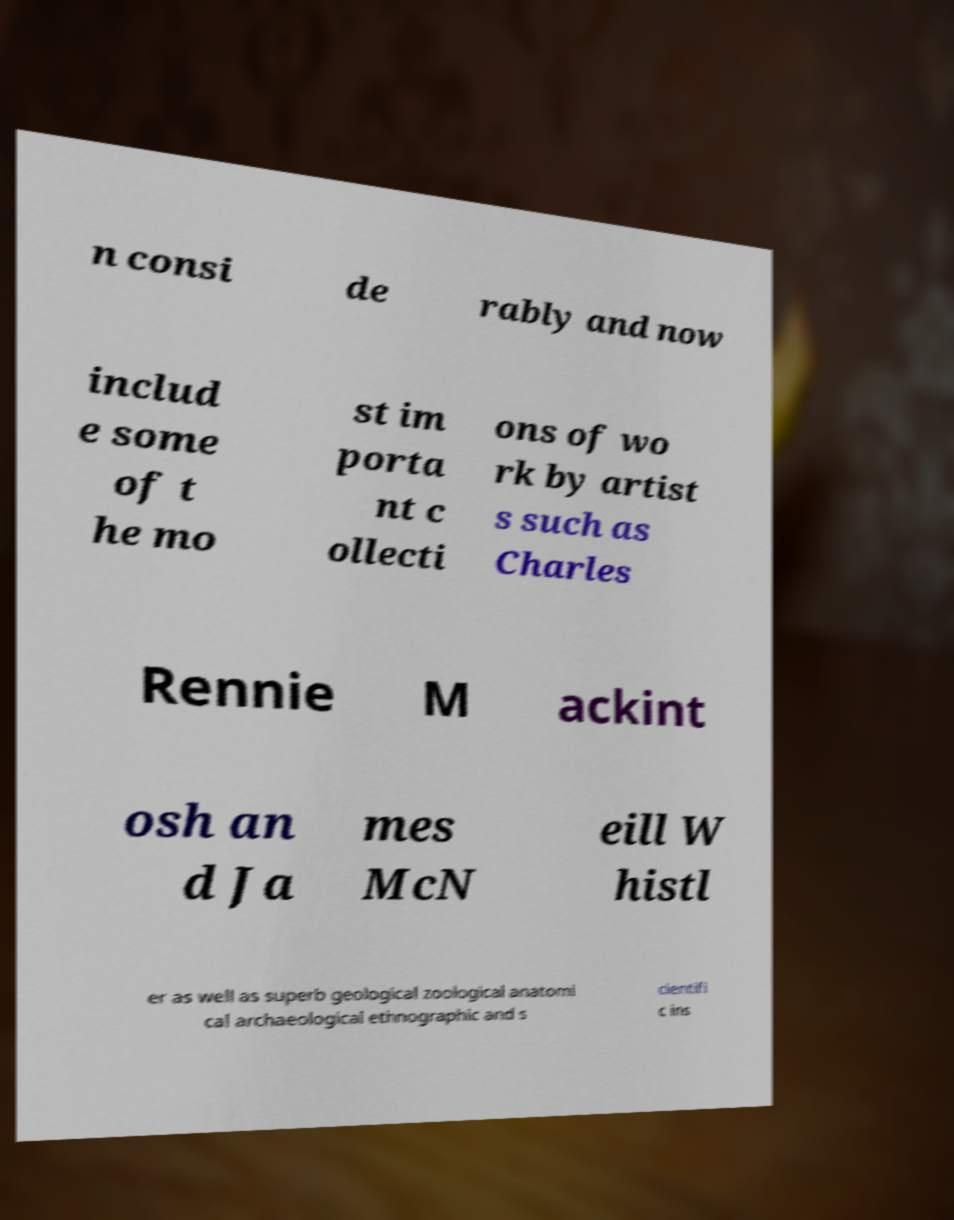Please identify and transcribe the text found in this image. n consi de rably and now includ e some of t he mo st im porta nt c ollecti ons of wo rk by artist s such as Charles Rennie M ackint osh an d Ja mes McN eill W histl er as well as superb geological zoological anatomi cal archaeological ethnographic and s cientifi c ins 